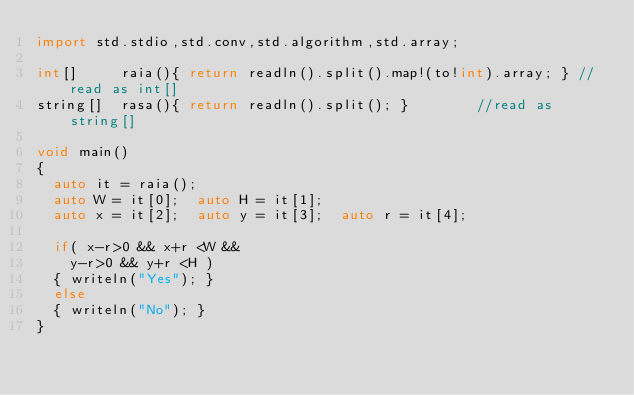<code> <loc_0><loc_0><loc_500><loc_500><_D_>import std.stdio,std.conv,std.algorithm,std.array;

int[] 		raia(){ return readln().split().map!(to!int).array; }	//read as int[]
string[]	rasa(){ return readln().split(); }				//read as string[]

void main()
{
	auto it = raia();
	auto W = it[0];  auto H = it[1];
	auto x = it[2];  auto y = it[3];  auto r = it[4];

	if( x-r>0 && x+r <W &&
		y-r>0 && y+r <H )
	{	writeln("Yes"); }
	else
	{	writeln("No"); }
}</code> 